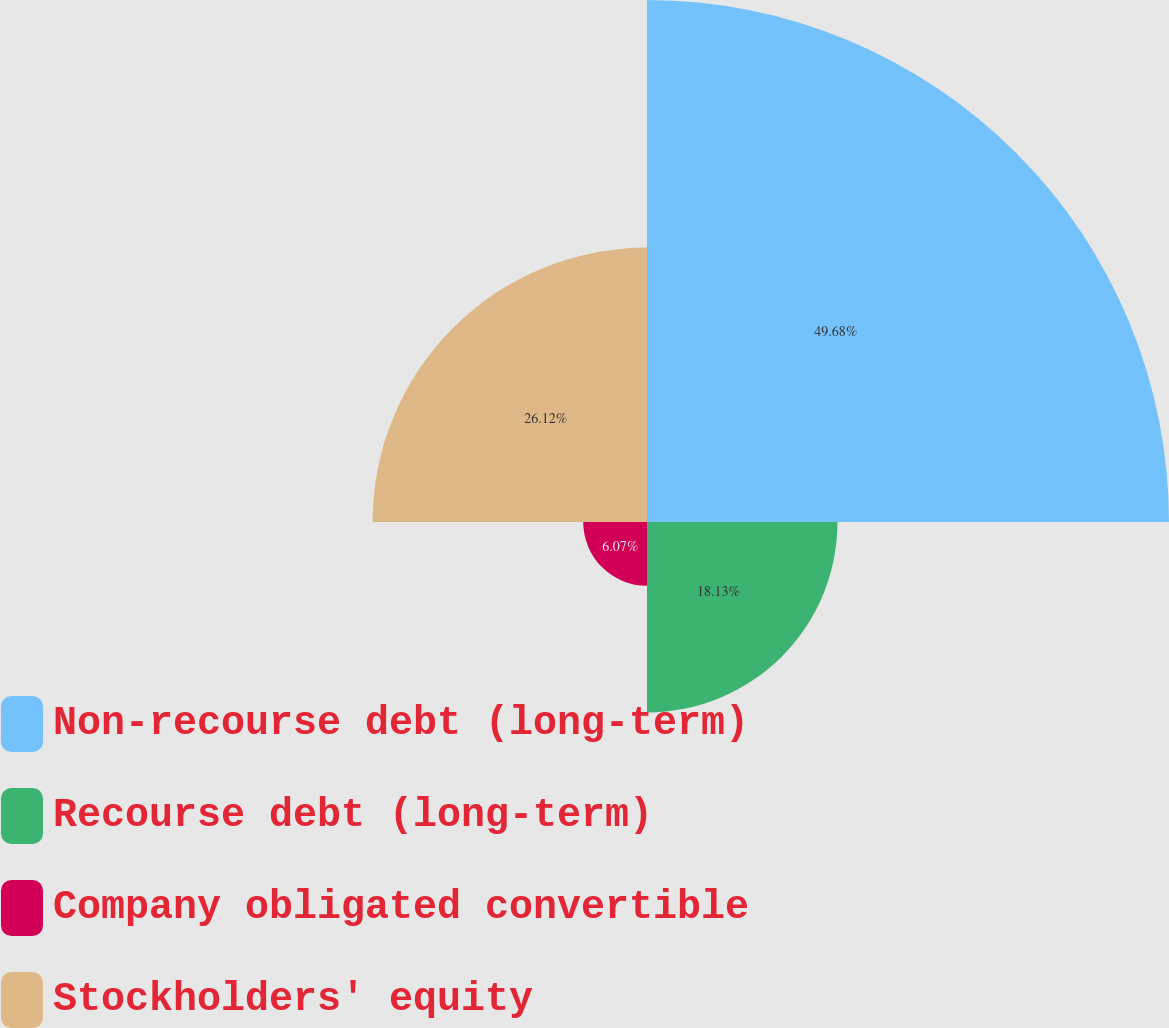Convert chart to OTSL. <chart><loc_0><loc_0><loc_500><loc_500><pie_chart><fcel>Non-recourse debt (long-term)<fcel>Recourse debt (long-term)<fcel>Company obligated convertible<fcel>Stockholders' equity<nl><fcel>49.69%<fcel>18.13%<fcel>6.07%<fcel>26.12%<nl></chart> 